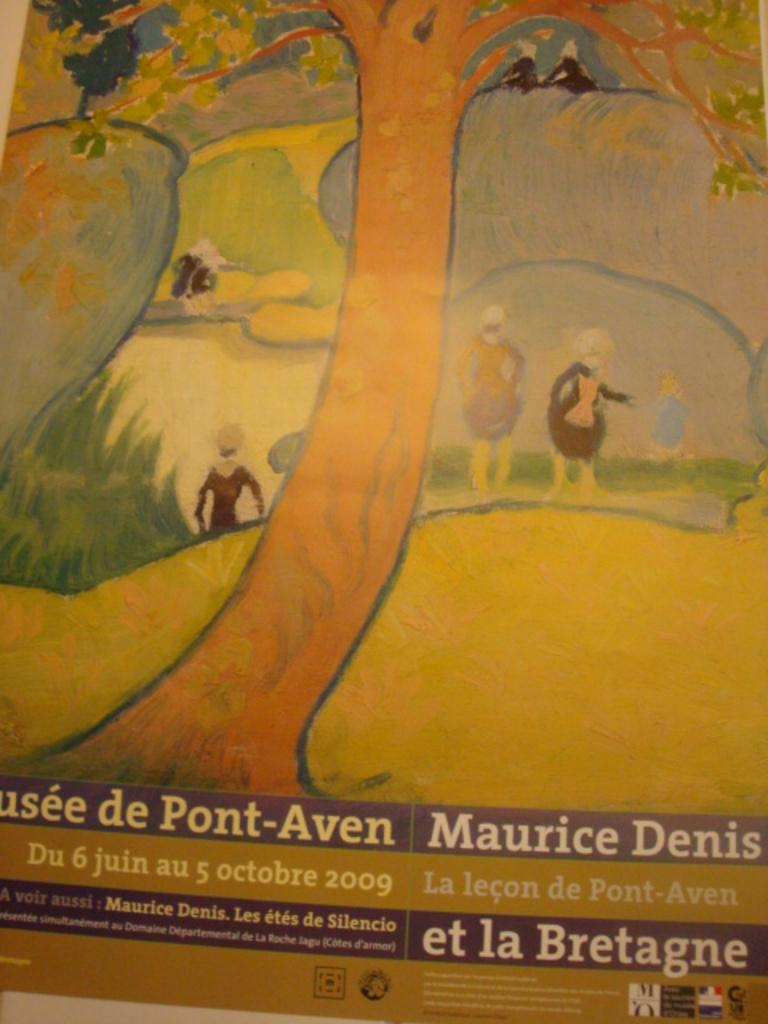<image>
Give a short and clear explanation of the subsequent image. A Maurice Denis painting is depicted on a sign for a museum. 